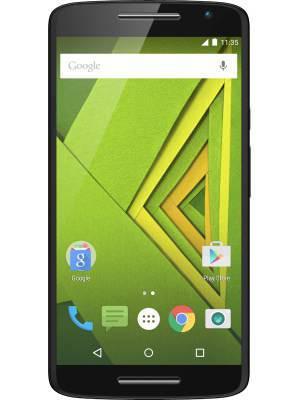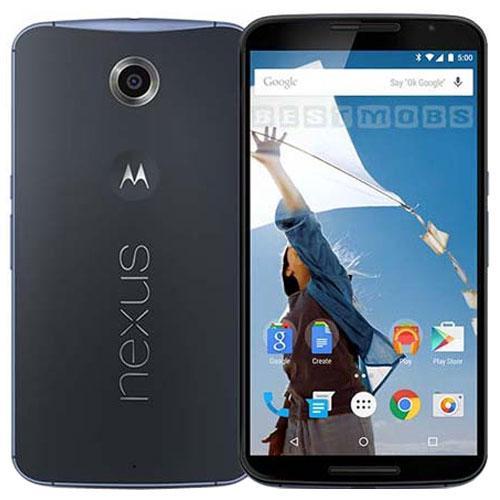The first image is the image on the left, the second image is the image on the right. For the images shown, is this caption "The right image shows exactly three phones, which are displayed upright and spaced apart instead of overlapping." true? Answer yes or no. No. The first image is the image on the left, the second image is the image on the right. Examine the images to the left and right. Is the description "The left and right image contains the same number of phones that a vertical." accurate? Answer yes or no. No. 